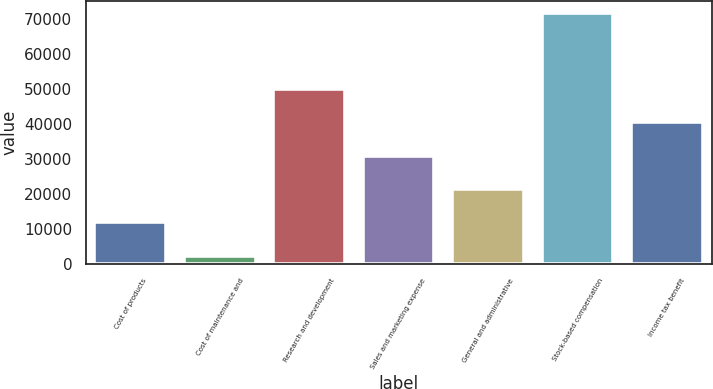<chart> <loc_0><loc_0><loc_500><loc_500><bar_chart><fcel>Cost of products<fcel>Cost of maintenance and<fcel>Research and development<fcel>Sales and marketing expense<fcel>General and administrative<fcel>Stock-based compensation<fcel>Income tax benefit<nl><fcel>11934.5<fcel>2418<fcel>50000.5<fcel>30967.5<fcel>21451<fcel>71616<fcel>40484<nl></chart> 